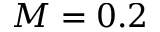<formula> <loc_0><loc_0><loc_500><loc_500>M = 0 . 2</formula> 